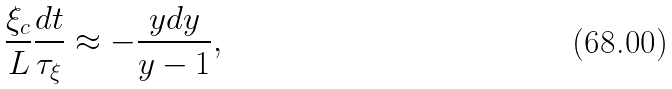Convert formula to latex. <formula><loc_0><loc_0><loc_500><loc_500>\frac { \xi _ { c } } { L } \frac { d t } { \tau _ { \xi } } \approx - \frac { y d y } { y - 1 } ,</formula> 